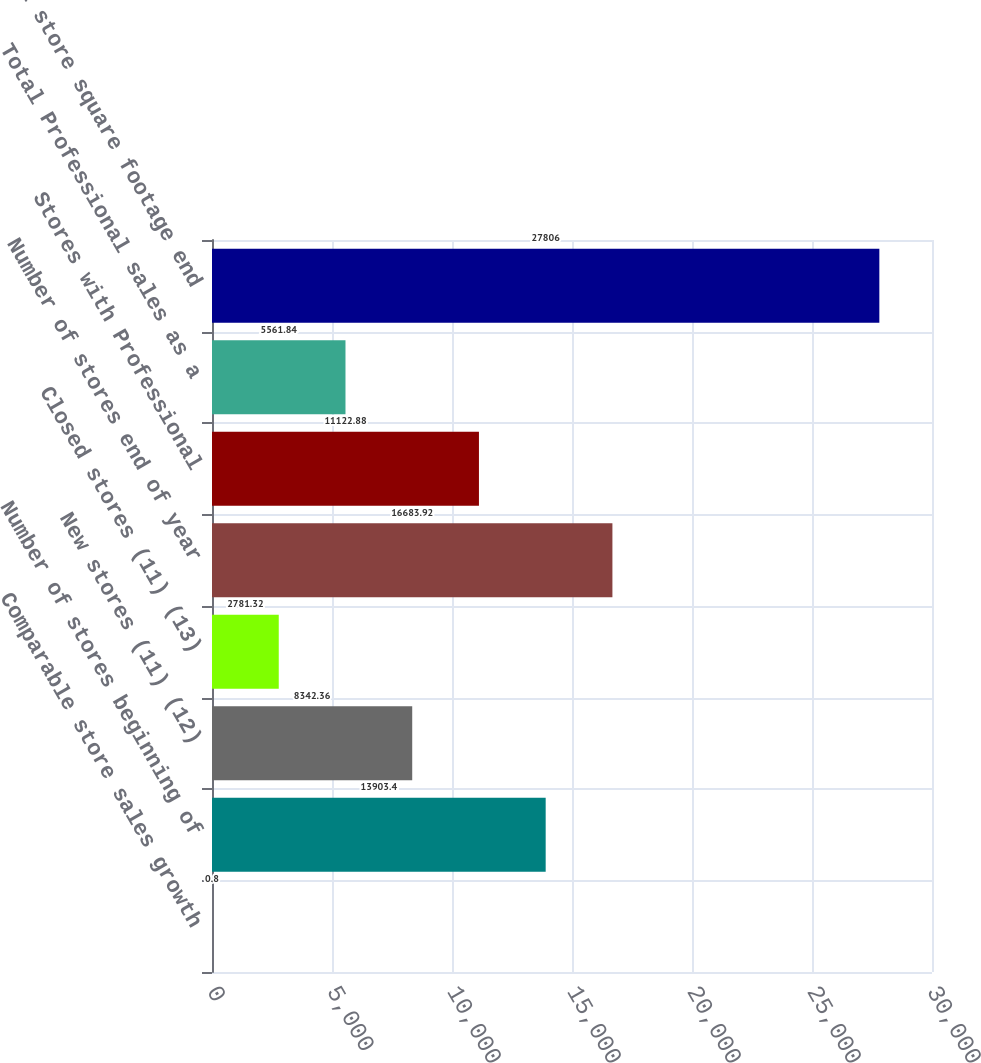<chart> <loc_0><loc_0><loc_500><loc_500><bar_chart><fcel>Comparable store sales growth<fcel>Number of stores beginning of<fcel>New stores (11) (12)<fcel>Closed stores (11) (13)<fcel>Number of stores end of year<fcel>Stores with Professional<fcel>Total Professional sales as a<fcel>Total store square footage end<nl><fcel>0.8<fcel>13903.4<fcel>8342.36<fcel>2781.32<fcel>16683.9<fcel>11122.9<fcel>5561.84<fcel>27806<nl></chart> 